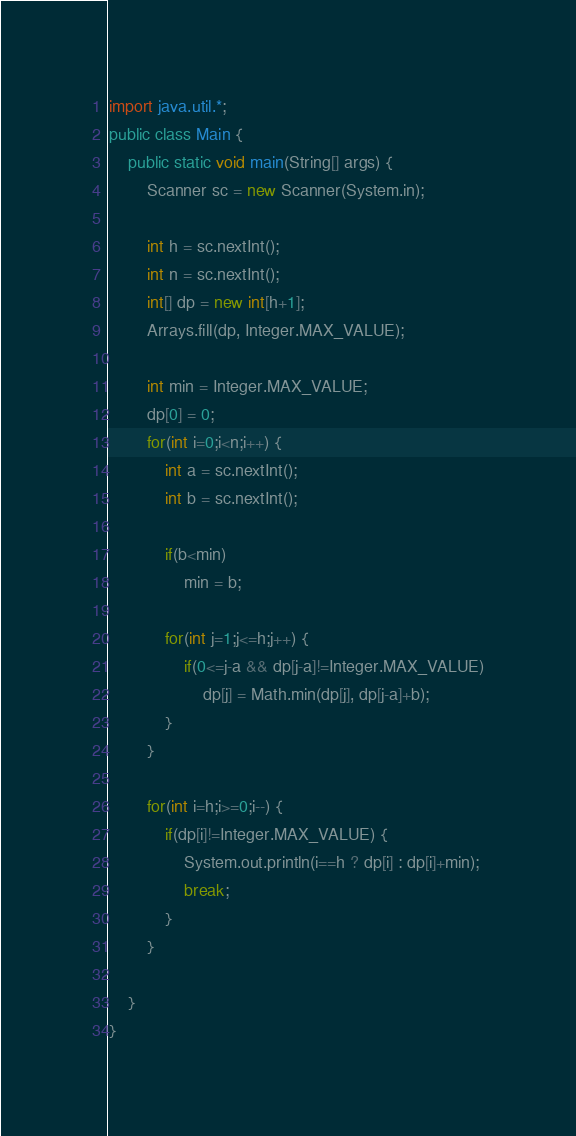Convert code to text. <code><loc_0><loc_0><loc_500><loc_500><_Java_>import java.util.*;
public class Main {
	public static void main(String[] args) {
		Scanner sc = new Scanner(System.in);
 
		int h = sc.nextInt();
		int n = sc.nextInt();
		int[] dp = new int[h+1];
		Arrays.fill(dp, Integer.MAX_VALUE);
		
		int min = Integer.MAX_VALUE;
		dp[0] = 0;
		for(int i=0;i<n;i++) {
			int a = sc.nextInt();
			int b = sc.nextInt();
			
			if(b<min)
				min = b;
			
			for(int j=1;j<=h;j++) {
				if(0<=j-a && dp[j-a]!=Integer.MAX_VALUE)
					dp[j] = Math.min(dp[j], dp[j-a]+b);
			}
		}
		
		for(int i=h;i>=0;i--) {
			if(dp[i]!=Integer.MAX_VALUE) {
				System.out.println(i==h ? dp[i] : dp[i]+min);
				break;
			}
		}
		
	}
}</code> 